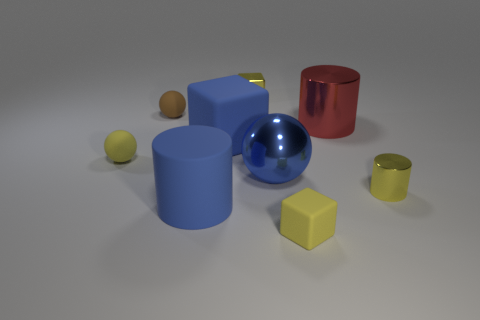What number of metallic things are either big gray things or balls?
Provide a succinct answer. 1. What number of yellow balls are behind the matte thing on the right side of the small yellow metal thing that is on the left side of the big red metal thing?
Offer a terse response. 1. There is a metallic cylinder that is to the right of the red metal cylinder; is its size the same as the block behind the big red metal cylinder?
Provide a succinct answer. Yes. What material is the yellow thing that is the same shape as the big blue metallic thing?
Your answer should be compact. Rubber. What number of big objects are gray metallic things or blue metallic balls?
Provide a succinct answer. 1. What is the material of the large red thing?
Provide a short and direct response. Metal. What is the big thing that is on the right side of the blue rubber cube and in front of the large block made of?
Offer a terse response. Metal. Does the big rubber cylinder have the same color as the block in front of the big blue matte cylinder?
Provide a short and direct response. No. What is the material of the other cube that is the same size as the yellow metal block?
Your answer should be very brief. Rubber. Are there any small yellow balls that have the same material as the tiny cylinder?
Keep it short and to the point. No. 